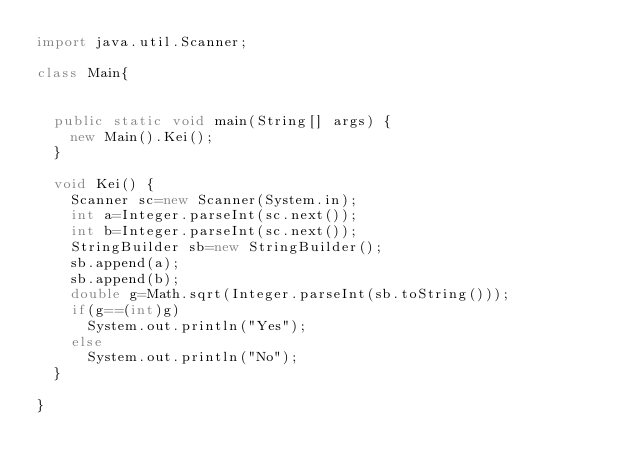Convert code to text. <code><loc_0><loc_0><loc_500><loc_500><_Java_>import java.util.Scanner;

class Main{
	
	
	public static void main(String[] args) {
		new Main().Kei();
	}
	
	void Kei() {
		Scanner sc=new Scanner(System.in);
		int a=Integer.parseInt(sc.next());
		int b=Integer.parseInt(sc.next());
		StringBuilder sb=new StringBuilder();
		sb.append(a);
		sb.append(b);
		double g=Math.sqrt(Integer.parseInt(sb.toString()));
		if(g==(int)g)
			System.out.println("Yes");
		else
			System.out.println("No");
	}
	
}


</code> 